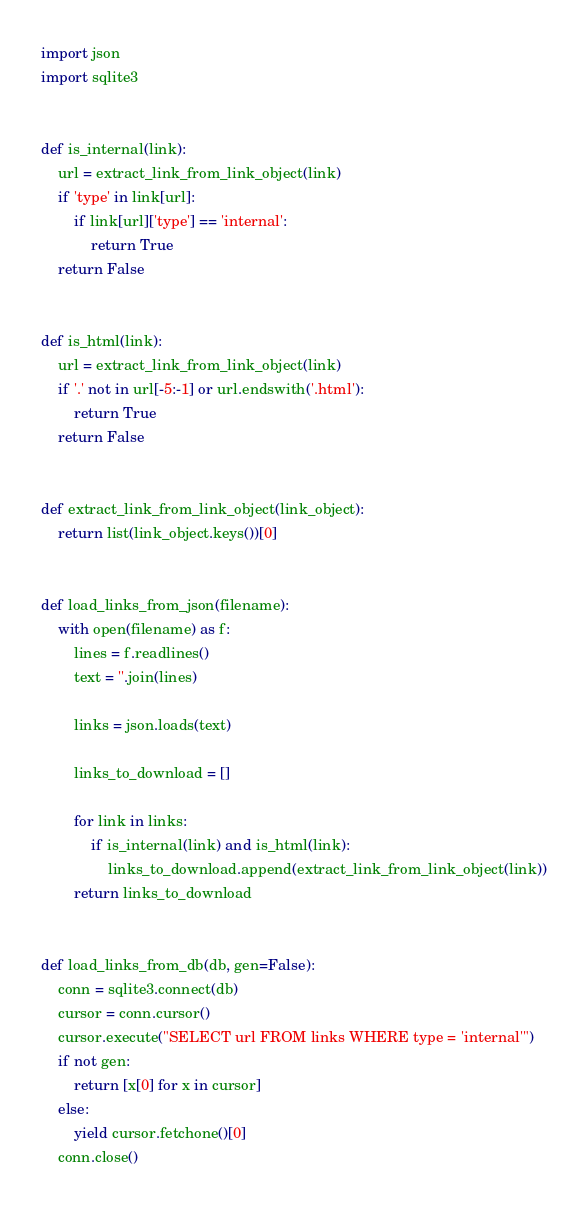<code> <loc_0><loc_0><loc_500><loc_500><_Python_>import json
import sqlite3


def is_internal(link):
    url = extract_link_from_link_object(link)
    if 'type' in link[url]:
        if link[url]['type'] == 'internal':
            return True
    return False


def is_html(link):
    url = extract_link_from_link_object(link)
    if '.' not in url[-5:-1] or url.endswith('.html'):
        return True
    return False


def extract_link_from_link_object(link_object):
    return list(link_object.keys())[0]


def load_links_from_json(filename):
    with open(filename) as f:
        lines = f.readlines()
        text = ''.join(lines)

        links = json.loads(text)

        links_to_download = []

        for link in links:
            if is_internal(link) and is_html(link):
                links_to_download.append(extract_link_from_link_object(link))
        return links_to_download


def load_links_from_db(db, gen=False):
    conn = sqlite3.connect(db)
    cursor = conn.cursor()
    cursor.execute("SELECT url FROM links WHERE type = 'internal'")
    if not gen:
        return [x[0] for x in cursor]
    else:
        yield cursor.fetchone()[0]
    conn.close()
</code> 